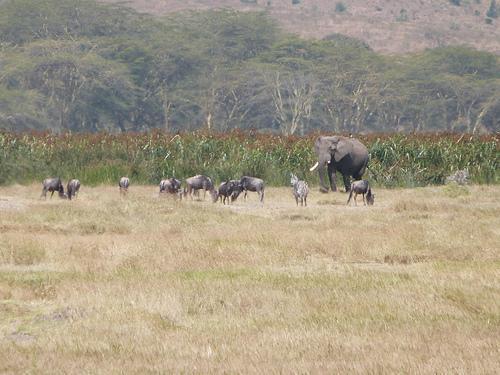How many animals are there?
Give a very brief answer. 12. How many elephants are there?
Give a very brief answer. 1. 